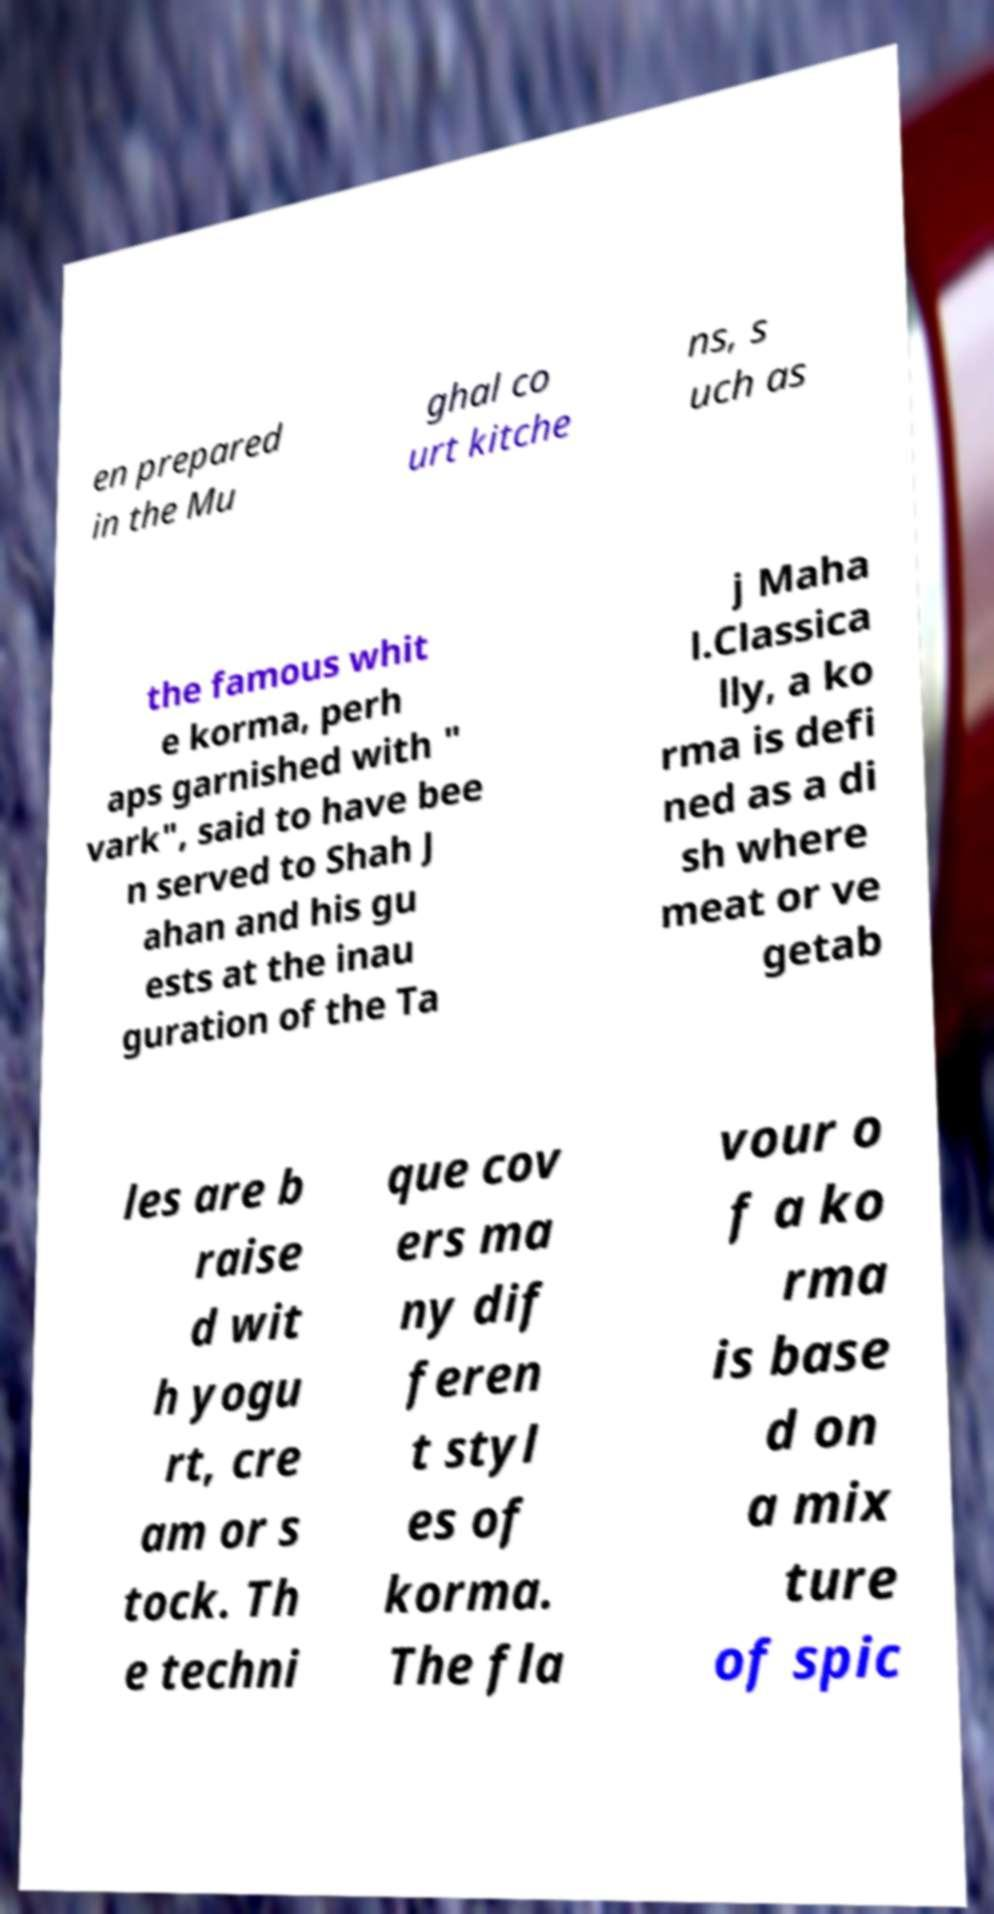What messages or text are displayed in this image? I need them in a readable, typed format. en prepared in the Mu ghal co urt kitche ns, s uch as the famous whit e korma, perh aps garnished with " vark", said to have bee n served to Shah J ahan and his gu ests at the inau guration of the Ta j Maha l.Classica lly, a ko rma is defi ned as a di sh where meat or ve getab les are b raise d wit h yogu rt, cre am or s tock. Th e techni que cov ers ma ny dif feren t styl es of korma. The fla vour o f a ko rma is base d on a mix ture of spic 